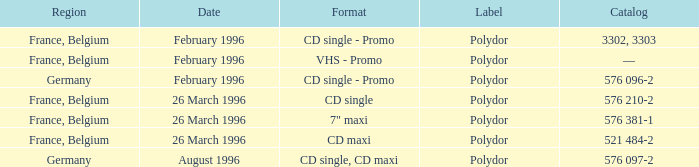Tell me the region for catalog of 576 096-2 Germany. 